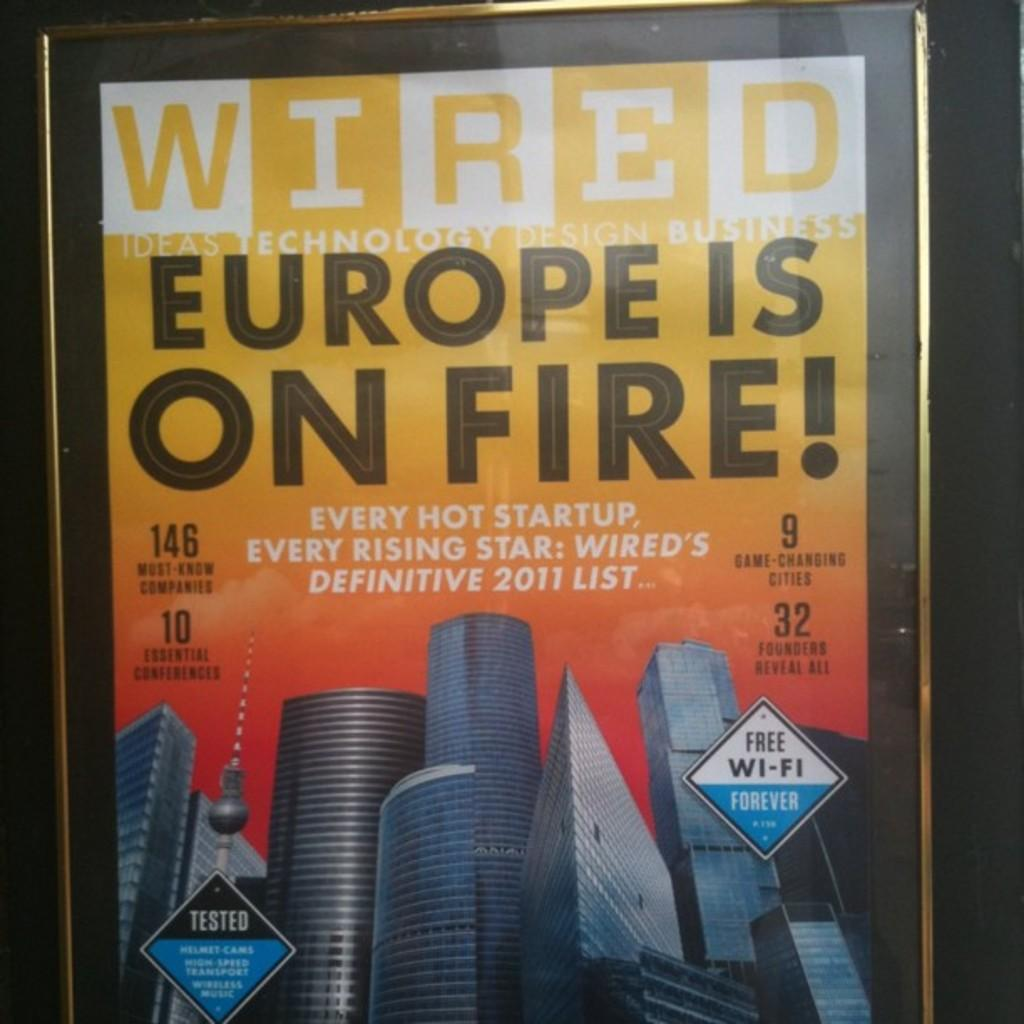What is present in the image that features a design or message? There is a poster in the image. What type of structures are shown on the poster? The poster has buildings depicted on it. What word is written on the poster? The word "Wired" is written on the poster. Are there any fairies depicted on the poster? No, there are no fairies depicted on the poster; it features buildings instead. 